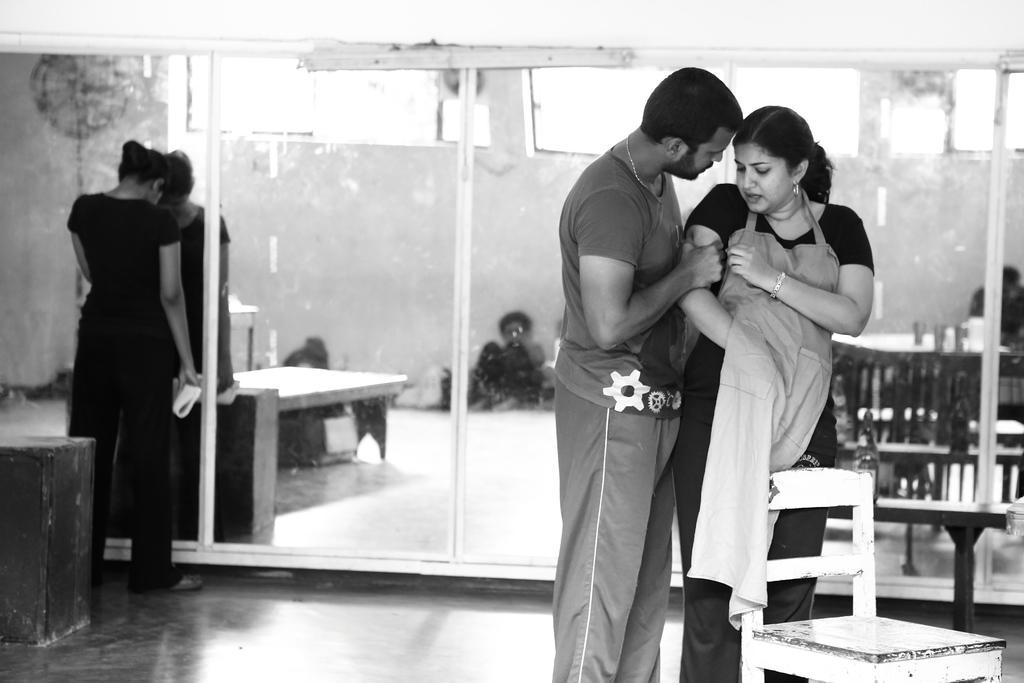Could you give a brief overview of what you see in this image? This is a black and white pic. On the right side we can see a man pressing the hand of a woman at the chair. On the left side we can see a person is standing on the floor. In the background we can see objects and glasses. We can see the reflections of few persons and objects in the glasses. 